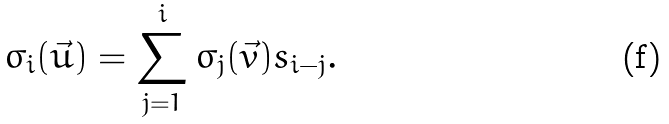<formula> <loc_0><loc_0><loc_500><loc_500>\sigma _ { i } ( \vec { u } ) = \sum _ { j = 1 } ^ { i } \sigma _ { j } ( \vec { v } ) s _ { i - j } .</formula> 